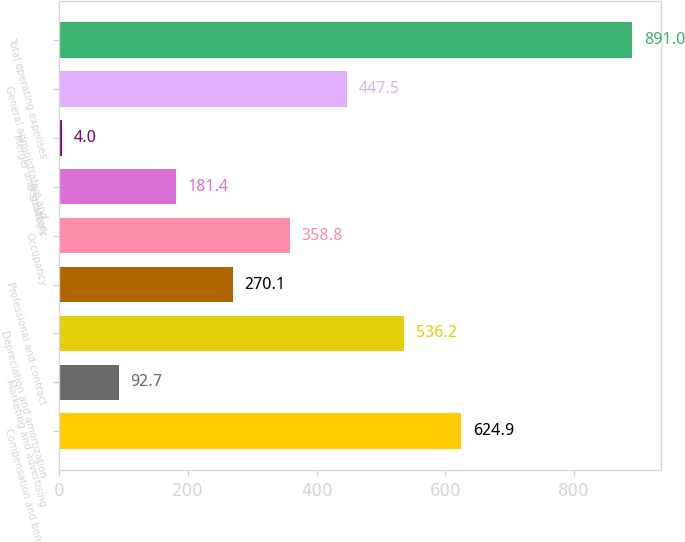Convert chart to OTSL. <chart><loc_0><loc_0><loc_500><loc_500><bar_chart><fcel>Compensation and benefits<fcel>Marketing and advertising<fcel>Depreciation and amortization<fcel>Professional and contract<fcel>Occupancy<fcel>Regulatory<fcel>Merger and strategic<fcel>General administrative and<fcel>Total operating expenses<nl><fcel>624.9<fcel>92.7<fcel>536.2<fcel>270.1<fcel>358.8<fcel>181.4<fcel>4<fcel>447.5<fcel>891<nl></chart> 